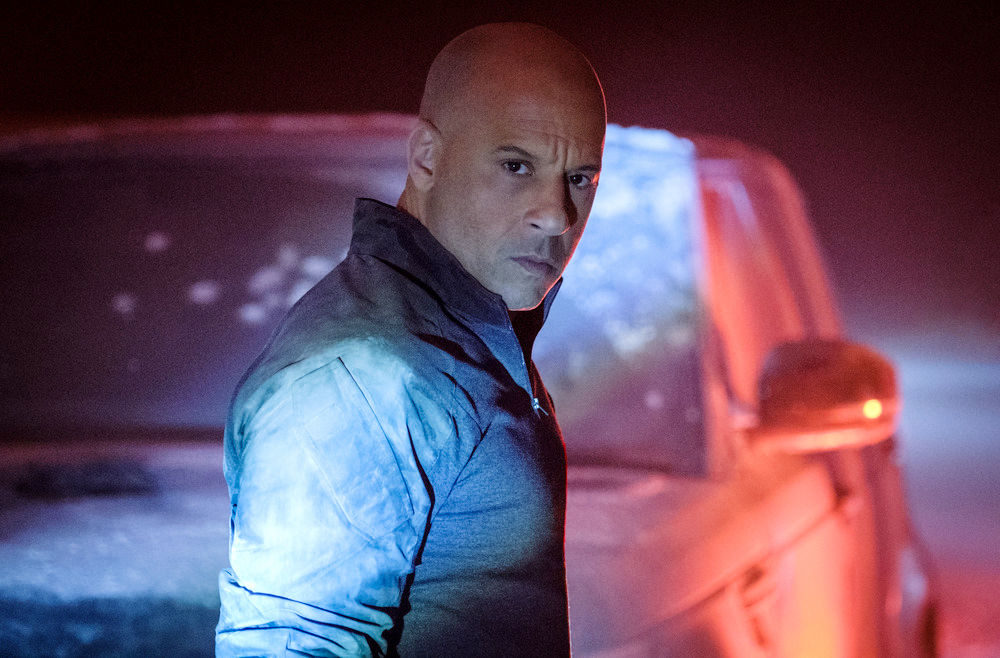What if the man in the image was transported to a medieval fantasy world? If the man in the image were transported to a medieval fantasy world, he might become a legendary warrior known as 'The Shadow Knight.' Armed with modern knowledge and strategies unbeknownst to the dwellers of this world, he would face mythical creatures, sorcerers, and treacherous nobles. In this new realm, he would gather a band of allies, including a wise mage, a skilled archer, and a loyal squire, setting out on epic quests to restore balance and justice. The foggy setting in the image would represent the mystical and uncertain nature of his new environment, filled with both danger and opportunity. 